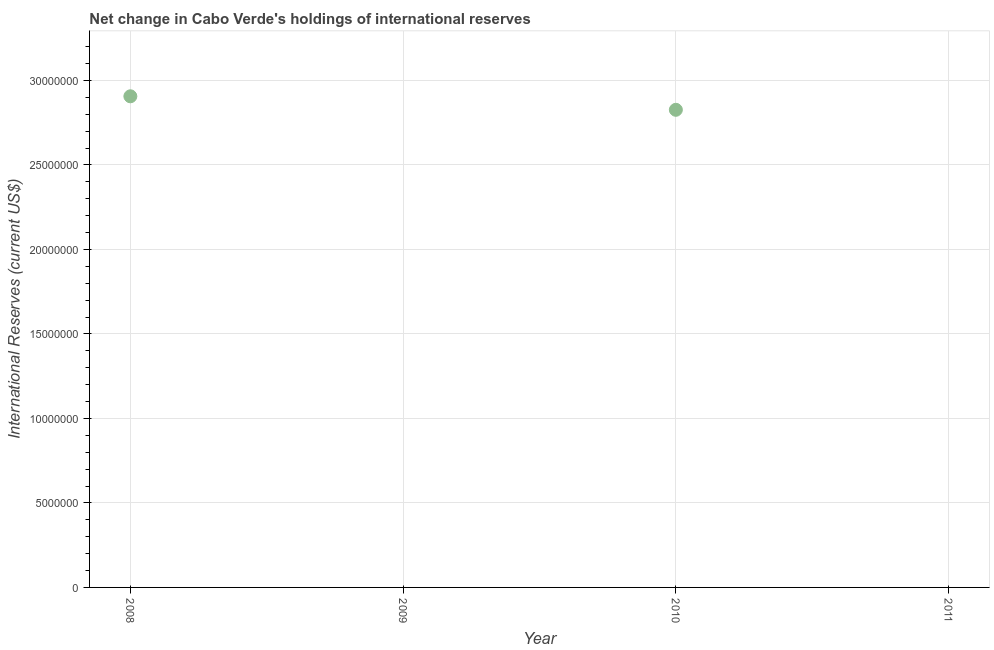Across all years, what is the maximum reserves and related items?
Offer a terse response. 2.91e+07. In which year was the reserves and related items maximum?
Your answer should be compact. 2008. What is the sum of the reserves and related items?
Provide a short and direct response. 5.73e+07. What is the average reserves and related items per year?
Provide a short and direct response. 1.43e+07. What is the median reserves and related items?
Your response must be concise. 1.41e+07. In how many years, is the reserves and related items greater than 25000000 US$?
Your answer should be very brief. 2. What is the ratio of the reserves and related items in 2008 to that in 2010?
Offer a very short reply. 1.03. What is the difference between the highest and the lowest reserves and related items?
Your answer should be very brief. 2.91e+07. In how many years, is the reserves and related items greater than the average reserves and related items taken over all years?
Offer a terse response. 2. How many dotlines are there?
Your answer should be very brief. 1. Are the values on the major ticks of Y-axis written in scientific E-notation?
Provide a short and direct response. No. What is the title of the graph?
Offer a terse response. Net change in Cabo Verde's holdings of international reserves. What is the label or title of the Y-axis?
Keep it short and to the point. International Reserves (current US$). What is the International Reserves (current US$) in 2008?
Keep it short and to the point. 2.91e+07. What is the International Reserves (current US$) in 2009?
Ensure brevity in your answer.  0. What is the International Reserves (current US$) in 2010?
Keep it short and to the point. 2.83e+07. What is the difference between the International Reserves (current US$) in 2008 and 2010?
Provide a succinct answer. 7.99e+05. What is the ratio of the International Reserves (current US$) in 2008 to that in 2010?
Ensure brevity in your answer.  1.03. 